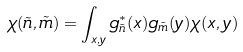<formula> <loc_0><loc_0><loc_500><loc_500>\chi ( \tilde { n } , \tilde { m } ) = \int _ { x , y } g _ { \tilde { n } } ^ { * } ( x ) g _ { \tilde { m } } ( y ) \chi ( x , y )</formula> 